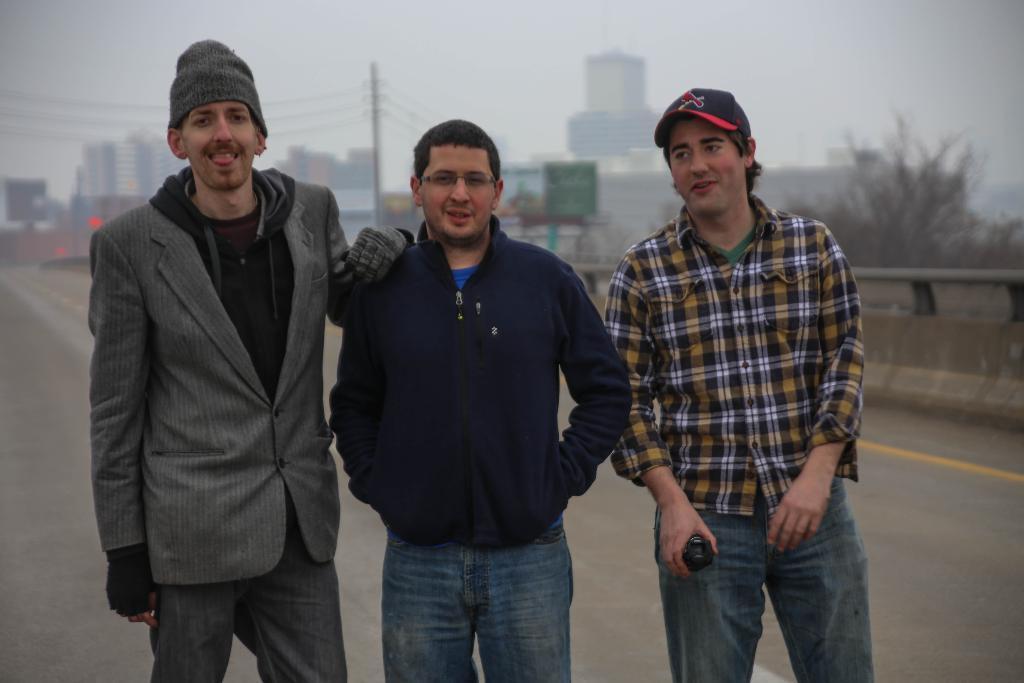Describe this image in one or two sentences. In the center of the image there are three persons standing on the road. in the background of the image there are buildings,electric poles,trees and sky. 